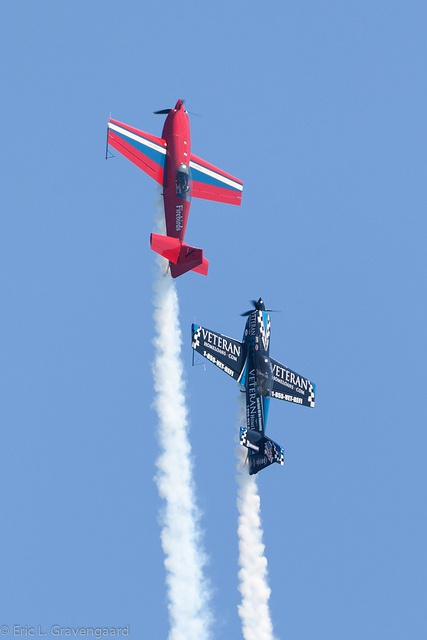Describe the objects in this image and their specific colors. I can see airplane in darkgray, salmon, purple, and brown tones and airplane in darkgray, navy, black, darkblue, and lightgray tones in this image. 